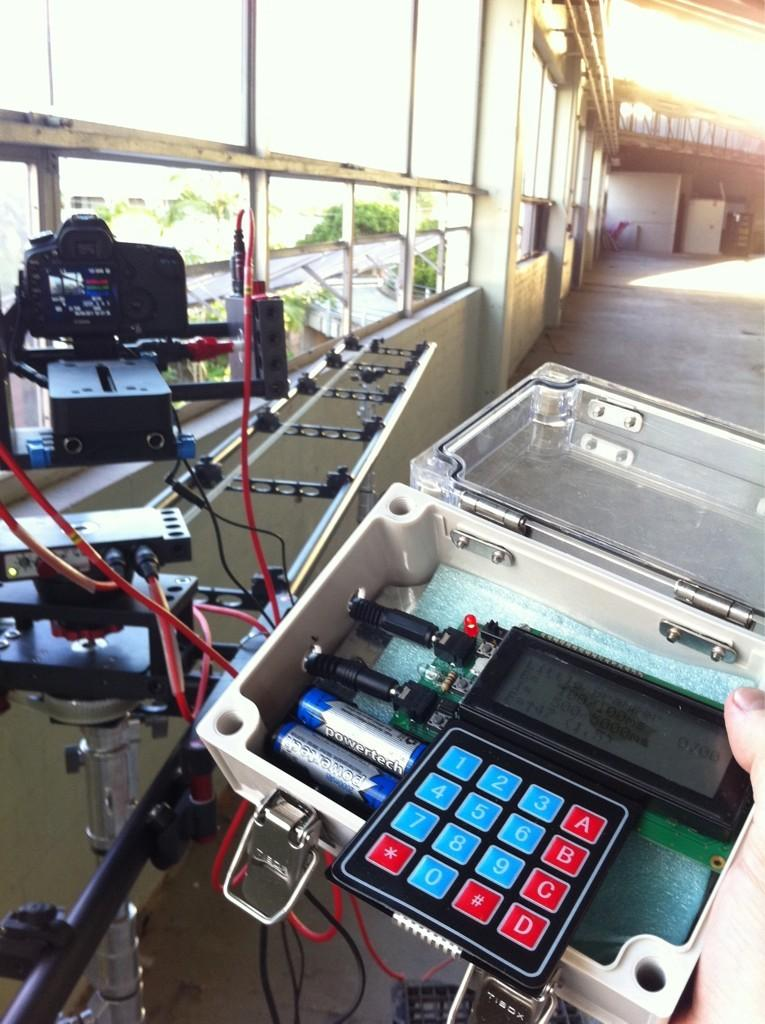What type of objects can be seen in the image? There are electronic objects in the image. Can you identify any specific electronic object in the image? Yes, there is a camera in the image. What architectural feature is visible in the image? There are windows in the image. What can be found in the top right corner of the image? There are objects in the top right corner of the image. What riddle is being solved by the milk in the image? There is no milk present in the image, and therefore no riddle can be solved by it. 